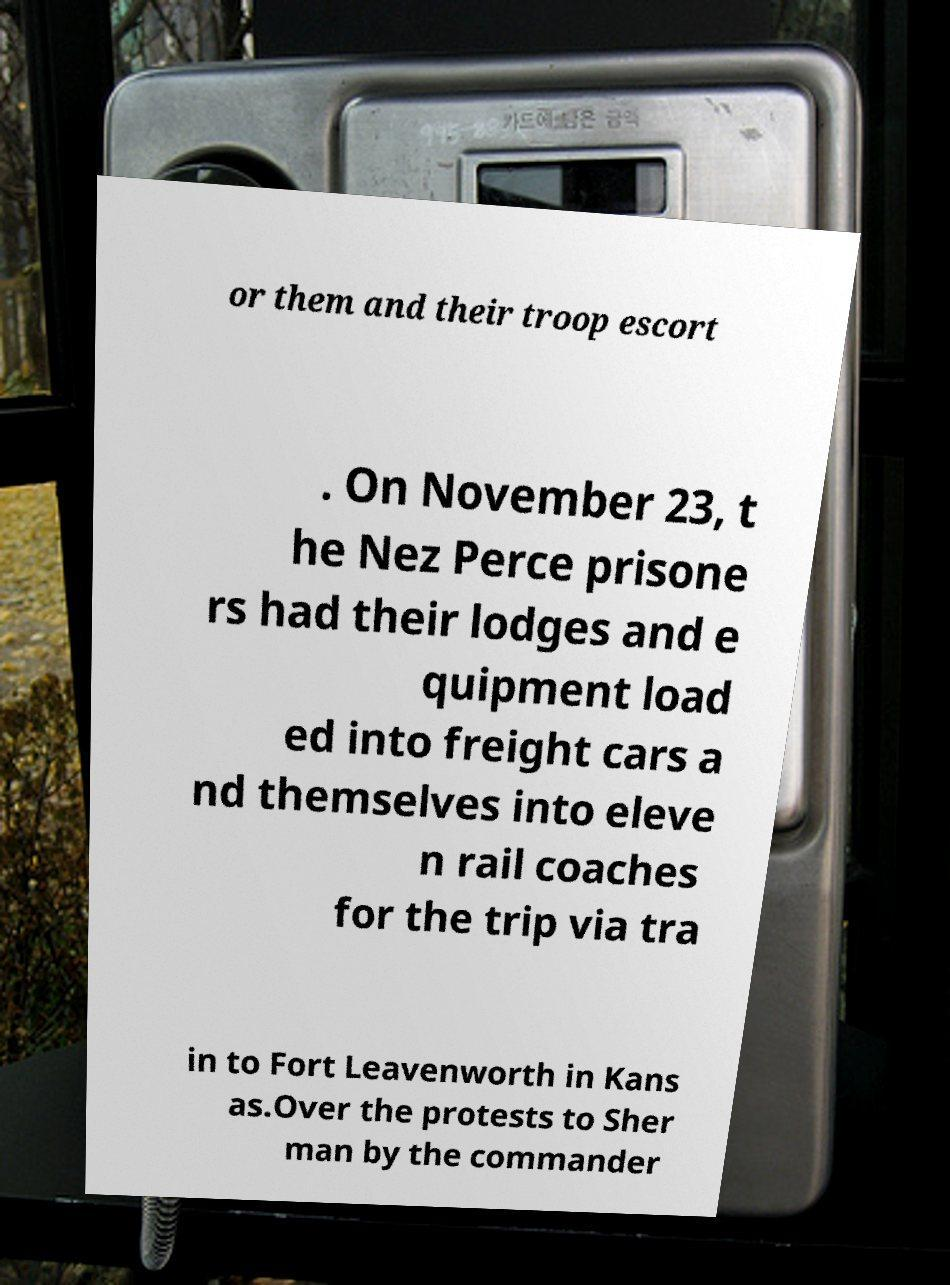Can you accurately transcribe the text from the provided image for me? or them and their troop escort . On November 23, t he Nez Perce prisone rs had their lodges and e quipment load ed into freight cars a nd themselves into eleve n rail coaches for the trip via tra in to Fort Leavenworth in Kans as.Over the protests to Sher man by the commander 